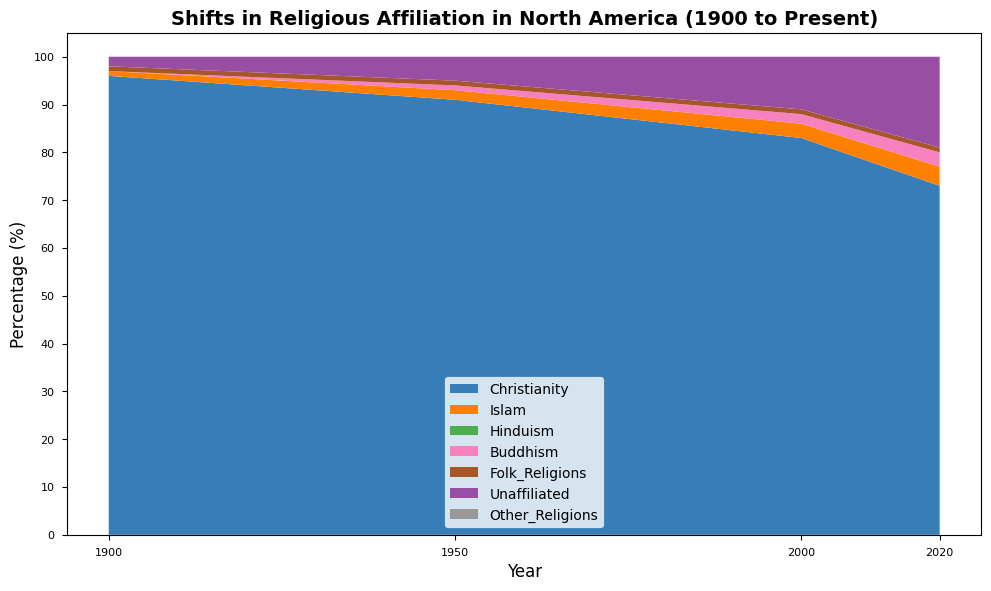What is the trend in the percentage of Unaffiliated individuals in North America from 1900 to 2020? The percentage of Unaffiliated individuals has increased over time. In 1900, it was 2%, then 5% in 1950, 11% in 2000, and 19% in 2020.
Answer: Increasing Which religion shows the highest steady growth in South Asia from 1900 to 2020? By reviewing the area chart for South Asia, Islam shows a consistent increase from 20% in 1900 to 40% in 2020.
Answer: Islam Compare the percentage of Christianity in Europe and North America in 2020. Which region has a higher percentage? In 2020, the percentage of Christianity in Europe is 65%, whereas in North America it is 73%. Therefore, North America has a higher percentage.
Answer: North America How has the percentage of people adhering to Folk Religions in Sub-Saharan Africa changed from 1900 to 2020? The percentage of people following Folk Religions in Sub-Saharan Africa decreased significantly from 54% in 1900 to 2% in 2020.
Answer: Decreased Looking at Asia-Pacific, which religion had the largest decrease in percentage from 1900 to 2020? Buddhism had the largest decrease, going from 25% in 1900 to 13% in 2020.
Answer: Buddhism What is the combined percentage of Buddhism and Hinduism in South Asia in 2000? In 2000, Buddhism is 5% and Hinduism is 53%. The combined percentage is 5% + 53% = 58%.
Answer: 58% Between 1900 and 2000, which region experienced the greatest increase in the percentage of Christianity? Sub-Saharan Africa experienced the greatest increase in Christianity from 9% in 1900 to 56% in 2000.
Answer: Sub-Saharan Africa In 2020, which region has the highest percentage of people who are Unaffiliated? North America has the highest percentage of Unaffiliated individuals at 19% in 2020.
Answer: North America What percentage of people followed Other Religions in Europe in 2020, and how does it compare to 1900? In 2020, 1% of people followed Other Religions in Europe, compared to 0% in 1900, showing a small increase.
Answer: 1%, increased Compare the trend of Islam in the Middle East-North Africa and Sub-Saharan Africa from 1900 to 2020. Which region had a more stable trend? The Middle East-North Africa shows a relatively stable trend of Islam percentages around 75%-88%, whereas Sub-Saharan Africa shows more variation, decreasing from 33% to 32%.
Answer: Middle East-North Africa 